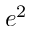Convert formula to latex. <formula><loc_0><loc_0><loc_500><loc_500>e ^ { 2 }</formula> 